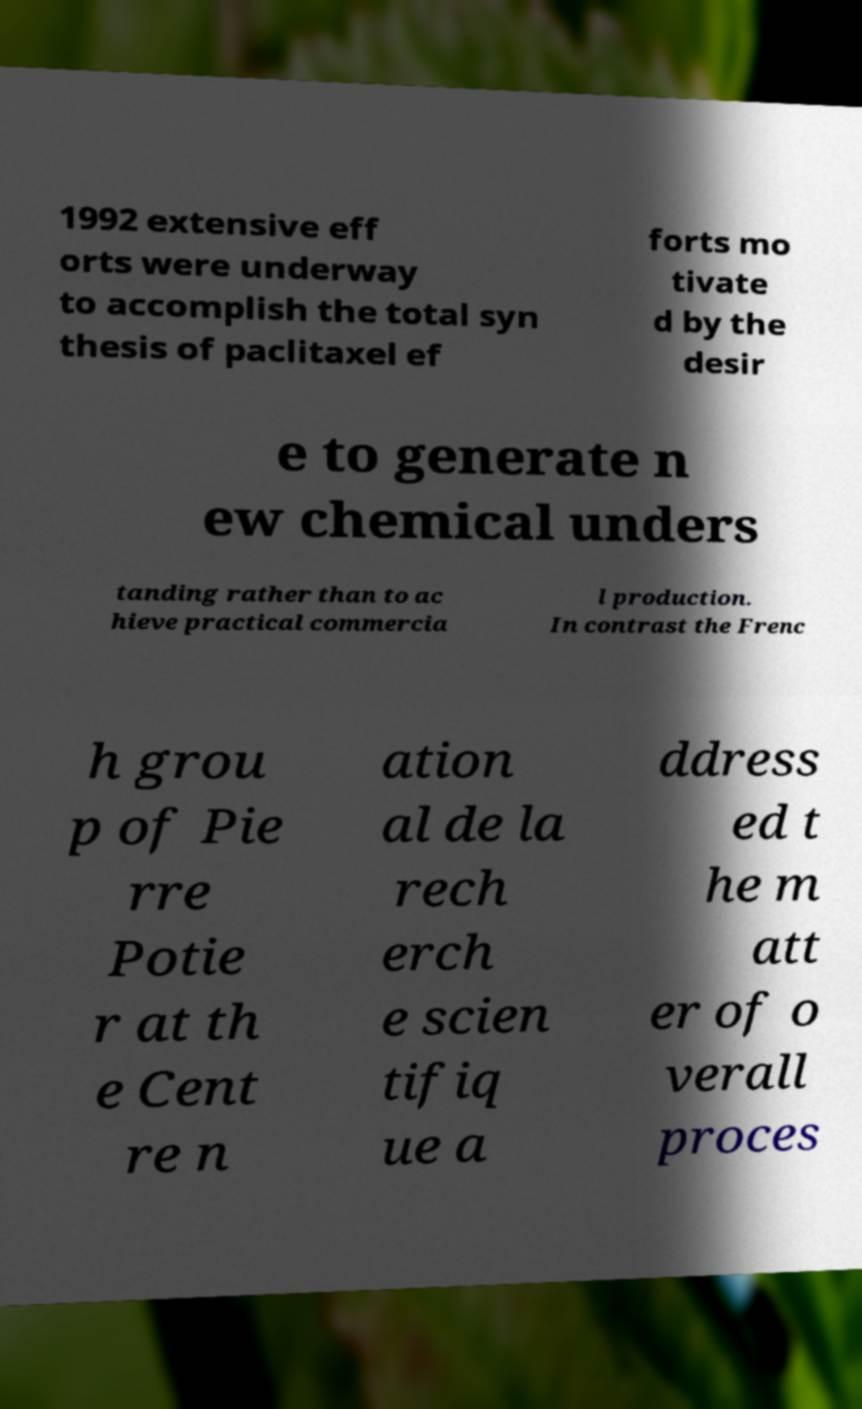Could you extract and type out the text from this image? 1992 extensive eff orts were underway to accomplish the total syn thesis of paclitaxel ef forts mo tivate d by the desir e to generate n ew chemical unders tanding rather than to ac hieve practical commercia l production. In contrast the Frenc h grou p of Pie rre Potie r at th e Cent re n ation al de la rech erch e scien tifiq ue a ddress ed t he m att er of o verall proces 